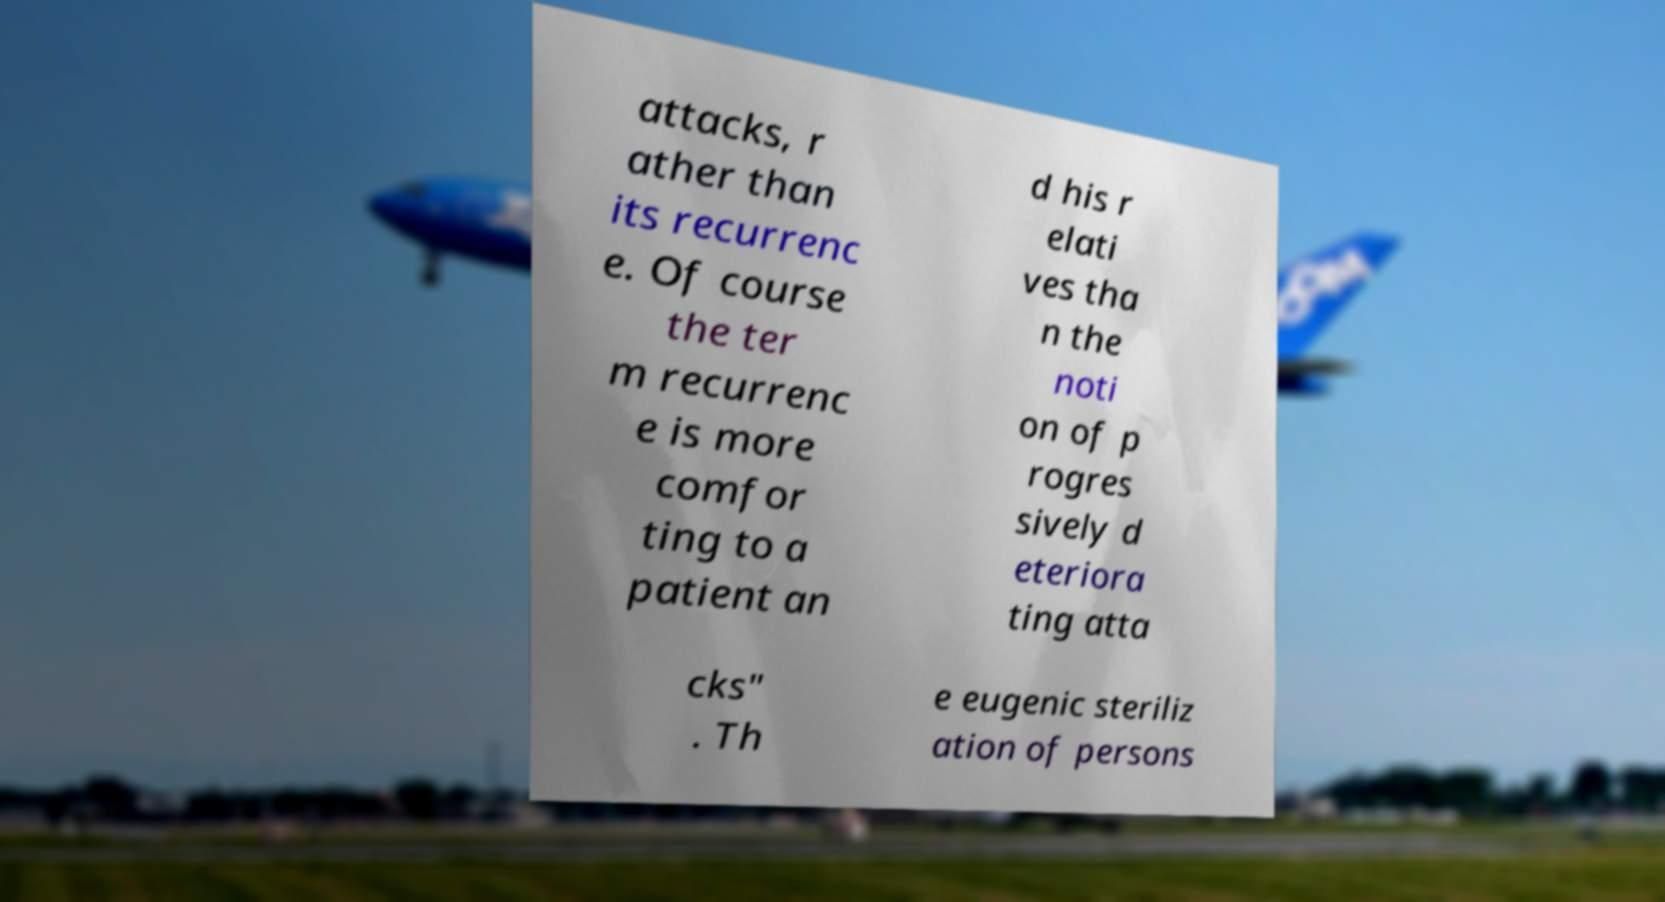Can you read and provide the text displayed in the image?This photo seems to have some interesting text. Can you extract and type it out for me? attacks, r ather than its recurrenc e. Of course the ter m recurrenc e is more comfor ting to a patient an d his r elati ves tha n the noti on of p rogres sively d eteriora ting atta cks" . Th e eugenic steriliz ation of persons 